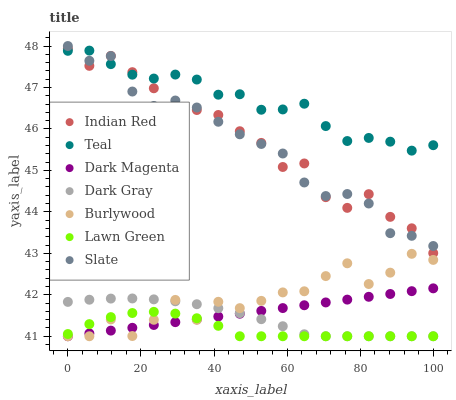Does Lawn Green have the minimum area under the curve?
Answer yes or no. Yes. Does Teal have the maximum area under the curve?
Answer yes or no. Yes. Does Indian Red have the minimum area under the curve?
Answer yes or no. No. Does Indian Red have the maximum area under the curve?
Answer yes or no. No. Is Dark Magenta the smoothest?
Answer yes or no. Yes. Is Burlywood the roughest?
Answer yes or no. Yes. Is Indian Red the smoothest?
Answer yes or no. No. Is Indian Red the roughest?
Answer yes or no. No. Does Lawn Green have the lowest value?
Answer yes or no. Yes. Does Indian Red have the lowest value?
Answer yes or no. No. Does Slate have the highest value?
Answer yes or no. Yes. Does Indian Red have the highest value?
Answer yes or no. No. Is Lawn Green less than Indian Red?
Answer yes or no. Yes. Is Slate greater than Burlywood?
Answer yes or no. Yes. Does Lawn Green intersect Dark Gray?
Answer yes or no. Yes. Is Lawn Green less than Dark Gray?
Answer yes or no. No. Is Lawn Green greater than Dark Gray?
Answer yes or no. No. Does Lawn Green intersect Indian Red?
Answer yes or no. No. 